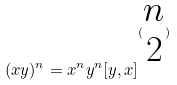<formula> <loc_0><loc_0><loc_500><loc_500>( x y ) ^ { n } = x ^ { n } y ^ { n } [ y , x ] ^ { ( \begin{matrix} n \\ 2 \end{matrix} ) }</formula> 